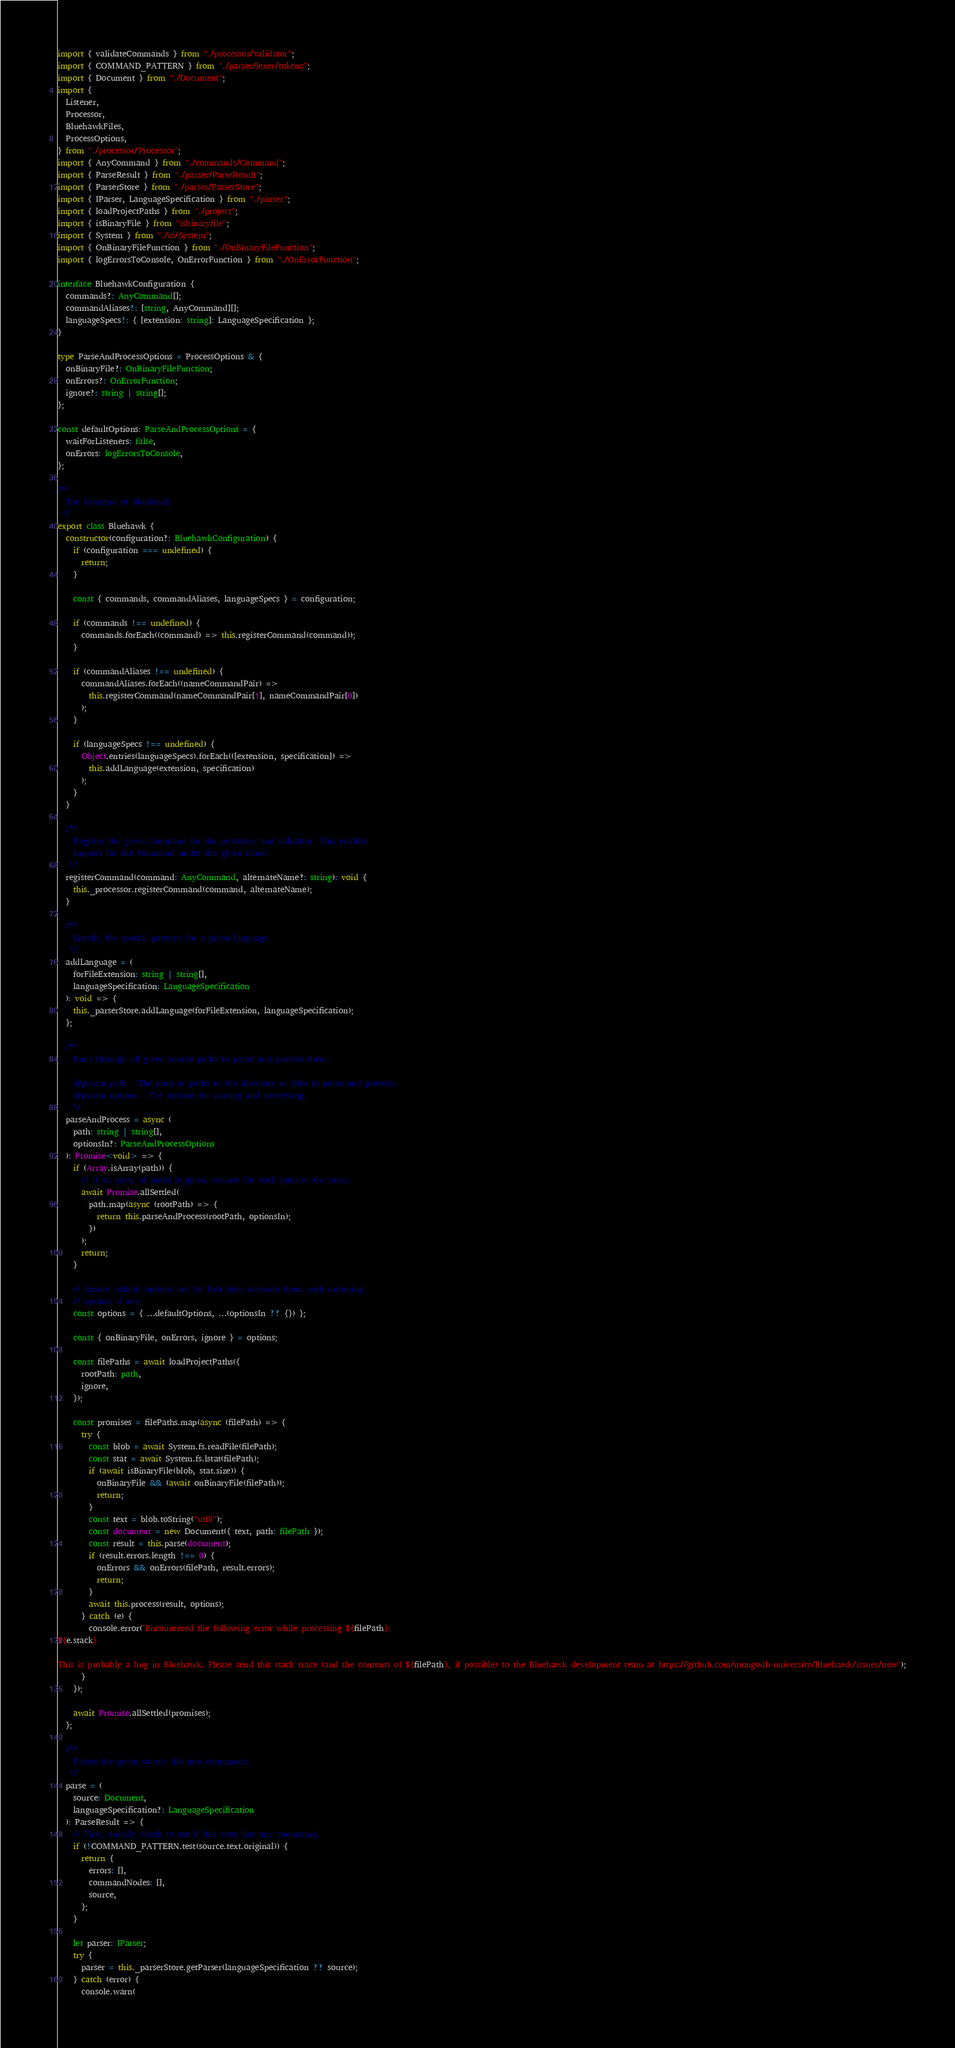<code> <loc_0><loc_0><loc_500><loc_500><_TypeScript_>import { validateCommands } from "./processor/validator";
import { COMMAND_PATTERN } from "./parser/lexer/tokens";
import { Document } from "./Document";
import {
  Listener,
  Processor,
  BluehawkFiles,
  ProcessOptions,
} from "./processor/Processor";
import { AnyCommand } from "./commands/Command";
import { ParseResult } from "./parser/ParseResult";
import { ParserStore } from "./parser/ParserStore";
import { IParser, LanguageSpecification } from "./parser";
import { loadProjectPaths } from "./project";
import { isBinaryFile } from "isbinaryfile";
import { System } from "./io/System";
import { OnBinaryFileFunction } from "./OnBinaryFileFunction";
import { logErrorsToConsole, OnErrorFunction } from "./OnErrorFunction";

interface BluehawkConfiguration {
  commands?: AnyCommand[];
  commandAliases?: [string, AnyCommand][];
  languageSpecs?: { [extension: string]: LanguageSpecification };
}

type ParseAndProcessOptions = ProcessOptions & {
  onBinaryFile?: OnBinaryFileFunction;
  onErrors?: OnErrorFunction;
  ignore?: string | string[];
};

const defaultOptions: ParseAndProcessOptions = {
  waitForListeners: false,
  onErrors: logErrorsToConsole,
};

/**
  The frontend of Bluehawk.
 */
export class Bluehawk {
  constructor(configuration?: BluehawkConfiguration) {
    if (configuration === undefined) {
      return;
    }

    const { commands, commandAliases, languageSpecs } = configuration;

    if (commands !== undefined) {
      commands.forEach((command) => this.registerCommand(command));
    }

    if (commandAliases !== undefined) {
      commandAliases.forEach((nameCommandPair) =>
        this.registerCommand(nameCommandPair[1], nameCommandPair[0])
      );
    }

    if (languageSpecs !== undefined) {
      Object.entries(languageSpecs).forEach(([extension, specification]) =>
        this.addLanguage(extension, specification)
      );
    }
  }

  /**
    Register the given command on the processor and validator. This enables
    support for the command under the given name.
   */
  registerCommand(command: AnyCommand, alternateName?: string): void {
    this._processor.registerCommand(command, alternateName);
  }

  /**
    Specify the special patterns for a given language.
   */
  addLanguage = (
    forFileExtension: string | string[],
    languageSpecification: LanguageSpecification
  ): void => {
    this._parserStore.addLanguage(forFileExtension, languageSpecification);
  };

  /**
    Runs through all given source paths to parse and process them.

    @param path - The path or paths to the directory or files to parse and process.
    @param options - The options for parsing and processing.
    */
  parseAndProcess = async (
    path: string | string[],
    optionsIn?: ParseAndProcessOptions
  ): Promise<void> => {
    if (Array.isArray(path)) {
      // If an array of paths is given, recurse for each path in the array.
      await Promise.allSettled(
        path.map(async (rootPath) => {
          return this.parseAndProcess(rootPath, optionsIn);
        })
      );
      return;
    }

    // Ensure default options are set first then override them with incoming
    // options if any
    const options = { ...defaultOptions, ...(optionsIn ?? {}) };

    const { onBinaryFile, onErrors, ignore } = options;

    const filePaths = await loadProjectPaths({
      rootPath: path,
      ignore,
    });

    const promises = filePaths.map(async (filePath) => {
      try {
        const blob = await System.fs.readFile(filePath);
        const stat = await System.fs.lstat(filePath);
        if (await isBinaryFile(blob, stat.size)) {
          onBinaryFile && (await onBinaryFile(filePath));
          return;
        }
        const text = blob.toString("utf8");
        const document = new Document({ text, path: filePath });
        const result = this.parse(document);
        if (result.errors.length !== 0) {
          onErrors && onErrors(filePath, result.errors);
          return;
        }
        await this.process(result, options);
      } catch (e) {
        console.error(`Encountered the following error while processing ${filePath}:
${e.stack}

This is probably a bug in Bluehawk. Please send this stack trace (and the contents of ${filePath}, if possible) to the Bluehawk development team at https://github.com/mongodb-university/Bluehawk/issues/new`);
      }
    });

    await Promise.allSettled(promises);
  };

  /**
    Parses the given source file into commands.
   */
  parse = (
    source: Document,
    languageSpecification?: LanguageSpecification
  ): ParseResult => {
    // First, quickly check to see if this even has any commands.
    if (!COMMAND_PATTERN.test(source.text.original)) {
      return {
        errors: [],
        commandNodes: [],
        source,
      };
    }

    let parser: IParser;
    try {
      parser = this._parserStore.getParser(languageSpecification ?? source);
    } catch (error) {
      console.warn(</code> 